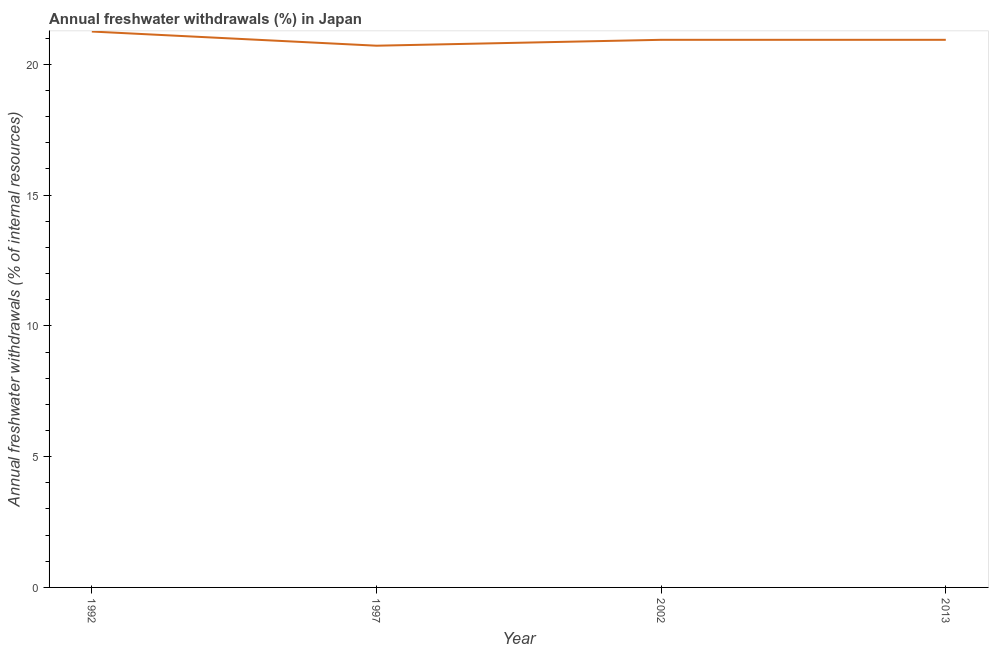What is the annual freshwater withdrawals in 2013?
Your response must be concise. 20.94. Across all years, what is the maximum annual freshwater withdrawals?
Your response must be concise. 21.26. Across all years, what is the minimum annual freshwater withdrawals?
Give a very brief answer. 20.71. In which year was the annual freshwater withdrawals minimum?
Offer a very short reply. 1997. What is the sum of the annual freshwater withdrawals?
Give a very brief answer. 83.85. What is the difference between the annual freshwater withdrawals in 1992 and 2002?
Keep it short and to the point. 0.32. What is the average annual freshwater withdrawals per year?
Offer a very short reply. 20.96. What is the median annual freshwater withdrawals?
Make the answer very short. 20.94. Do a majority of the years between 2002 and 1992 (inclusive) have annual freshwater withdrawals greater than 19 %?
Provide a short and direct response. No. What is the ratio of the annual freshwater withdrawals in 1992 to that in 1997?
Make the answer very short. 1.03. What is the difference between the highest and the second highest annual freshwater withdrawals?
Provide a succinct answer. 0.32. What is the difference between the highest and the lowest annual freshwater withdrawals?
Offer a terse response. 0.54. How many years are there in the graph?
Your answer should be compact. 4. Are the values on the major ticks of Y-axis written in scientific E-notation?
Provide a succinct answer. No. Does the graph contain grids?
Provide a short and direct response. No. What is the title of the graph?
Offer a terse response. Annual freshwater withdrawals (%) in Japan. What is the label or title of the Y-axis?
Provide a short and direct response. Annual freshwater withdrawals (% of internal resources). What is the Annual freshwater withdrawals (% of internal resources) in 1992?
Your answer should be compact. 21.26. What is the Annual freshwater withdrawals (% of internal resources) of 1997?
Keep it short and to the point. 20.71. What is the Annual freshwater withdrawals (% of internal resources) in 2002?
Give a very brief answer. 20.94. What is the Annual freshwater withdrawals (% of internal resources) of 2013?
Ensure brevity in your answer.  20.94. What is the difference between the Annual freshwater withdrawals (% of internal resources) in 1992 and 1997?
Keep it short and to the point. 0.54. What is the difference between the Annual freshwater withdrawals (% of internal resources) in 1992 and 2002?
Ensure brevity in your answer.  0.32. What is the difference between the Annual freshwater withdrawals (% of internal resources) in 1992 and 2013?
Give a very brief answer. 0.32. What is the difference between the Annual freshwater withdrawals (% of internal resources) in 1997 and 2002?
Your answer should be compact. -0.23. What is the difference between the Annual freshwater withdrawals (% of internal resources) in 1997 and 2013?
Your answer should be very brief. -0.23. What is the ratio of the Annual freshwater withdrawals (% of internal resources) in 1992 to that in 1997?
Provide a succinct answer. 1.03. What is the ratio of the Annual freshwater withdrawals (% of internal resources) in 1992 to that in 2002?
Keep it short and to the point. 1.01. 